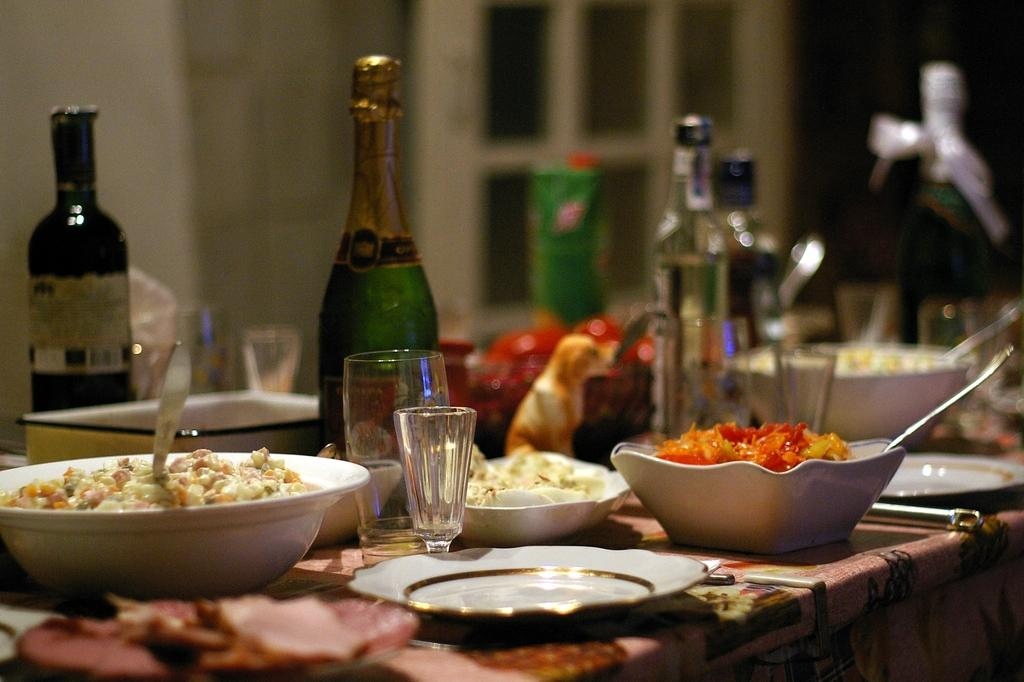Where was the image taken? The image was taken in a room. What furniture is present in the room? There is a table in the room. What items are on the table? There is a bowl, a spoon, a glass, a bottle, and a box on the table. What is the background of the table? The background of the table is a wall. How many buns are on the table in the image? There are no buns present on the table in the image. What type of air is visible in the image? There is no air visible in the image, as air is an invisible substance. 